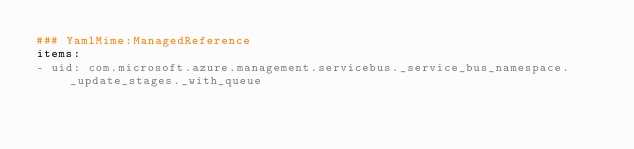<code> <loc_0><loc_0><loc_500><loc_500><_YAML_>### YamlMime:ManagedReference
items:
- uid: com.microsoft.azure.management.servicebus._service_bus_namespace._update_stages._with_queue</code> 